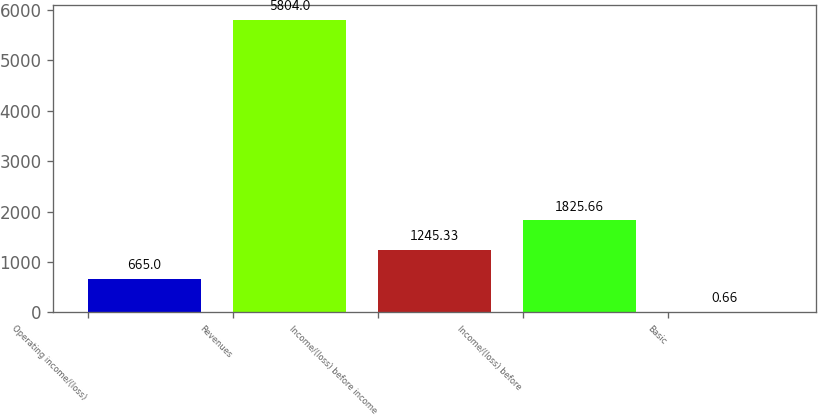<chart> <loc_0><loc_0><loc_500><loc_500><bar_chart><fcel>Operating income/(loss)<fcel>Revenues<fcel>Income/(loss) before income<fcel>Income/(loss) before<fcel>Basic<nl><fcel>665<fcel>5804<fcel>1245.33<fcel>1825.66<fcel>0.66<nl></chart> 